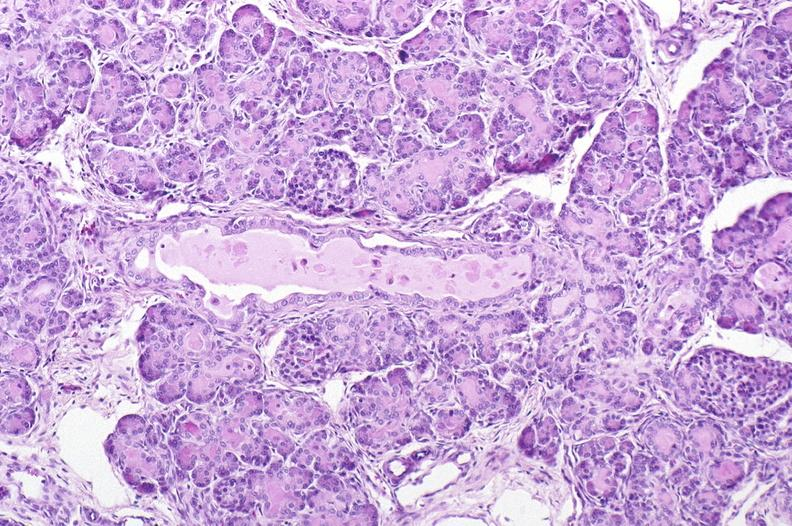what does this image show?
Answer the question using a single word or phrase. Cystic fibrosis 